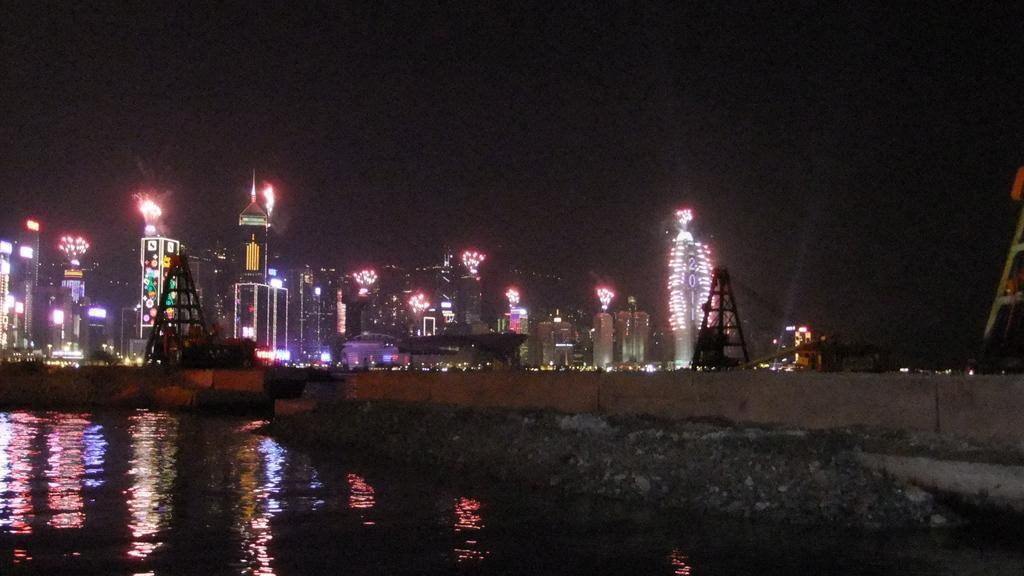In one or two sentences, can you explain what this image depicts? In this image I can see the water, a bridge, few buildings, few towers and few lights. In the background I can see the dark sky. 